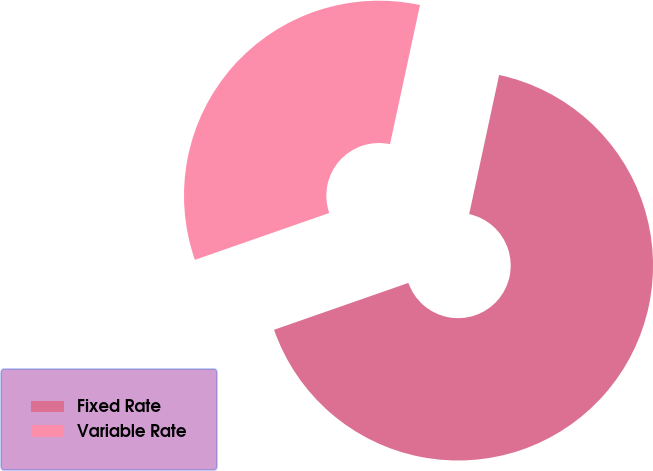Convert chart. <chart><loc_0><loc_0><loc_500><loc_500><pie_chart><fcel>Fixed Rate<fcel>Variable Rate<nl><fcel>66.28%<fcel>33.72%<nl></chart> 